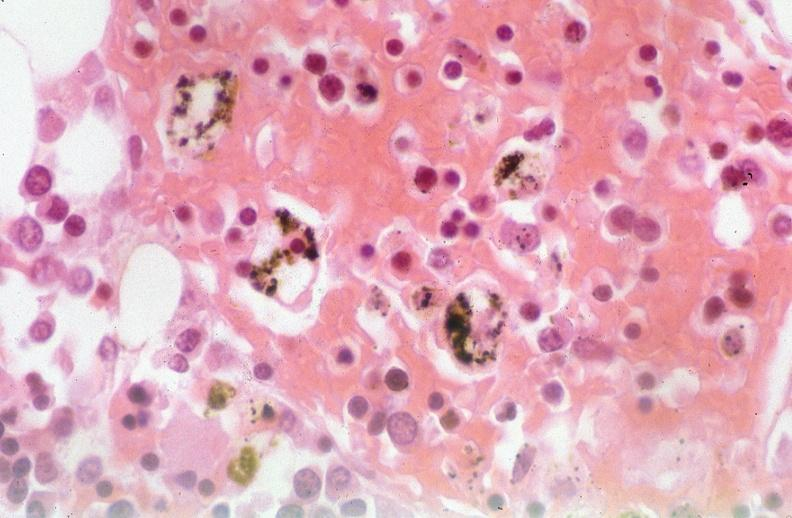was talc used to sclerose emphysematous lung, alpha-1 antitrypsin deficiency?
Answer the question using a single word or phrase. Yes 